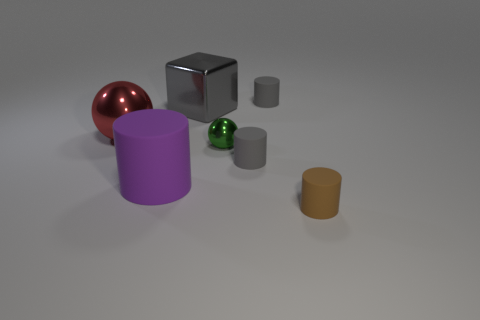How many tiny gray things are made of the same material as the big cube?
Provide a succinct answer. 0. There is a small sphere that is the same material as the big red object; what is its color?
Your answer should be very brief. Green. What is the material of the gray cylinder that is right of the tiny gray rubber cylinder on the left side of the gray matte object that is behind the green metal object?
Your answer should be very brief. Rubber. Is the size of the cylinder that is behind the gray shiny object the same as the cube?
Provide a short and direct response. No. How many tiny things are gray rubber cylinders or green shiny cylinders?
Your answer should be compact. 2. Is there a metal ball that has the same color as the big matte thing?
Offer a terse response. No. There is a rubber object that is the same size as the block; what is its shape?
Your answer should be compact. Cylinder. There is a big metal thing in front of the big gray metal block; is it the same color as the block?
Your answer should be compact. No. What number of objects are either small rubber objects that are behind the green thing or tiny gray balls?
Make the answer very short. 1. Is the number of tiny gray matte objects to the left of the big gray block greater than the number of large purple cylinders that are right of the small green object?
Your response must be concise. No. 